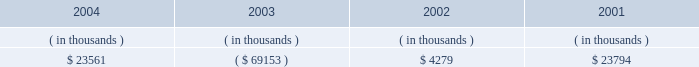Entergy arkansas , inc .
Management's financial discussion and analysis operating activities cash flow from operations increased $ 8.8 million in 2004 compared to 2003 primarily due to income tax benefits received in 2004 , and increased recovery of deferred fuel costs .
This increase was substantially offset by money pool activity .
In 2003 , the domestic utility companies and system energy filed , with the irs , a change in tax accounting method notification for their respective calculations of cost of goods sold .
The adjustment implemented a simplified method of allocation of overhead to the production of electricity , which is provided under the irs capitalization regulations .
The cumulative adjustment placing these companies on the new methodology resulted in a $ 1.171 billion deduction for entergy arkansas on entergy's 2003 income tax return .
There was no cash benefit from the method change in 2003 .
In 2004 , entergy arkansas realized $ 173 million in cash tax benefit from the method change .
This tax accounting method change is an issue across the utility industry and will likely be challenged by the irs on audit .
As of december 31 , 2004 , entergy arkansas has a net operating loss ( nol ) carryforward for tax purposes of $ 766.9 million , principally resulting from the change in tax accounting method related to cost of goods sold .
If the tax accounting method change is sustained , entergy arkansas expects to utilize the nol carryforward through 2006 .
Cash flow from operations increased $ 80.1 million in 2003 compared to 2002 primarily due to income taxes paid of $ 2.2 million in 2003 compared to income taxes paid of $ 83.9 million in 2002 , and money pool activity .
This increase was partially offset by decreased recovery of deferred fuel costs in 2003 .
Entergy arkansas' receivables from or ( payables to ) the money pool were as follows as of december 31 for each of the following years: .
Money pool activity used $ 92.7 million of entergy arkansas' operating cash flow in 2004 , provided $ 73.4 million in 2003 , and provided $ 19.5 million in 2002 .
See note 4 to the domestic utility companies and system energy financial statements for a description of the money pool .
Investing activities the decrease of $ 68.1 million in net cash used in investing activities in 2004 compared to 2003 was primarily due to a decrease in construction expenditures resulting from less transmission upgrade work requested by merchant generators in 2004 combined with lower spending on customer support projects in 2004 .
The increase of $ 88.1 million in net cash used in investing activities in 2003 compared to 2002 was primarily due to an increase in construction expenditures of $ 57.4 million and the maturity of $ 38.4 million of other temporary investments in the first quarter of 2002 .
Construction expenditures increased in 2003 primarily due to the following : 2022 a ferc ruling that shifted responsibility for transmission upgrade work performed for independent power producers to entergy arkansas ; and 2022 the ano 1 steam generator , reactor vessel head , and transformer replacement project .
Financing activities the decrease of $ 90.7 million in net cash used in financing activities in 2004 compared to 2003 was primarily due to the net redemption of $ 2.4 million of long-term debt in 2004 compared to $ 109.3 million in 2003 , partially offset by the payment of $ 16.2 million more in common stock dividends during the same period. .
What portion of the increase in net cash used in investing activities in 2003 is due to an increase in construction expenditures? 
Computations: (57.4 / 88.1)
Answer: 0.65153. 